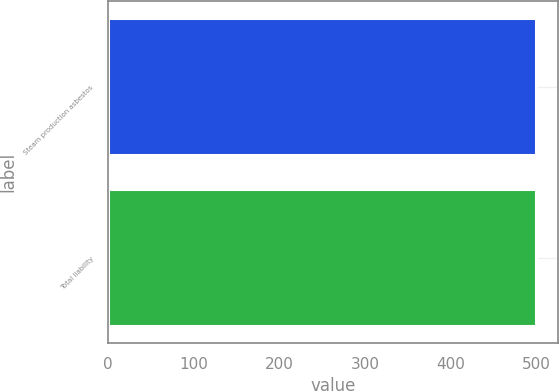<chart> <loc_0><loc_0><loc_500><loc_500><bar_chart><fcel>Steam production asbestos<fcel>Total liability<nl><fcel>500<fcel>500.1<nl></chart> 